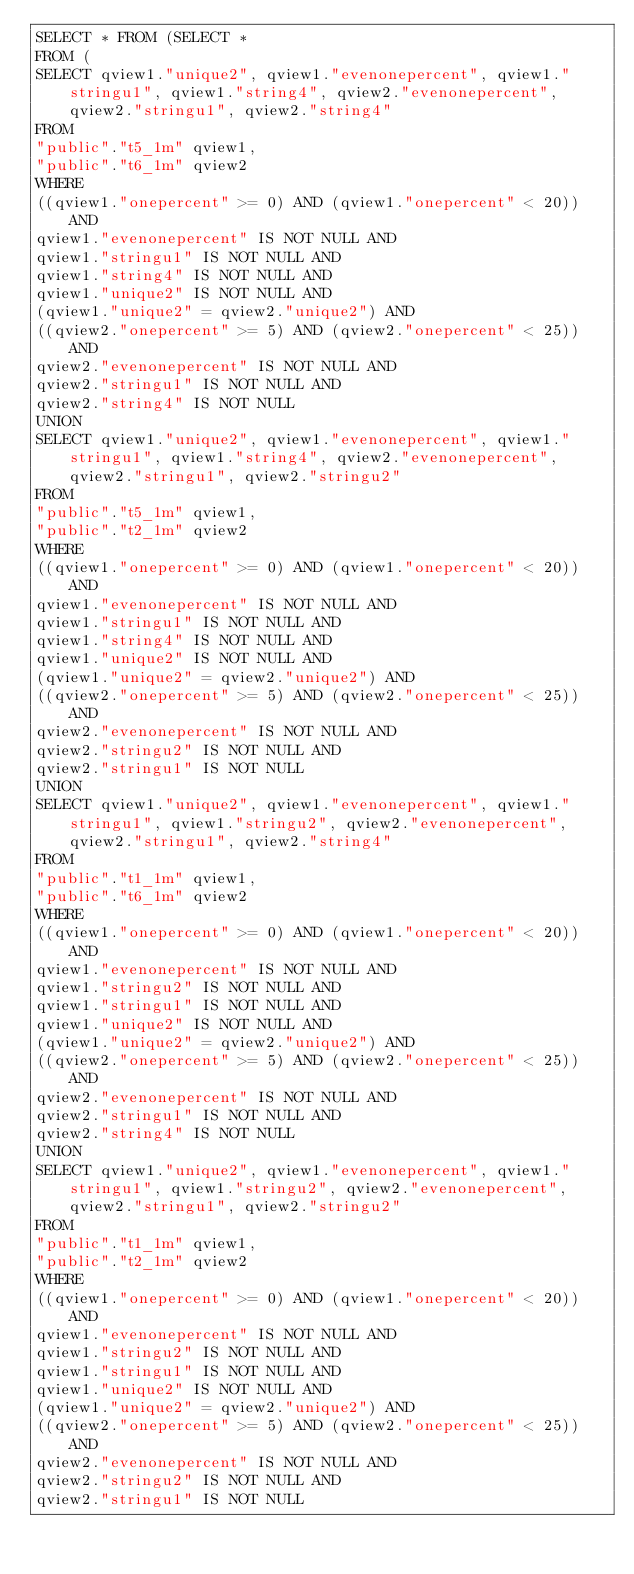Convert code to text. <code><loc_0><loc_0><loc_500><loc_500><_SQL_>SELECT * FROM (SELECT *
FROM (
SELECT qview1."unique2", qview1."evenonepercent", qview1."stringu1", qview1."string4", qview2."evenonepercent", qview2."stringu1", qview2."string4"
FROM
"public"."t5_1m" qview1,
"public"."t6_1m" qview2
WHERE
((qview1."onepercent" >= 0) AND (qview1."onepercent" < 20)) AND
qview1."evenonepercent" IS NOT NULL AND
qview1."stringu1" IS NOT NULL AND
qview1."string4" IS NOT NULL AND
qview1."unique2" IS NOT NULL AND
(qview1."unique2" = qview2."unique2") AND
((qview2."onepercent" >= 5) AND (qview2."onepercent" < 25)) AND
qview2."evenonepercent" IS NOT NULL AND
qview2."stringu1" IS NOT NULL AND
qview2."string4" IS NOT NULL
UNION
SELECT qview1."unique2", qview1."evenonepercent", qview1."stringu1", qview1."string4", qview2."evenonepercent", qview2."stringu1", qview2."stringu2"
FROM
"public"."t5_1m" qview1,
"public"."t2_1m" qview2
WHERE
((qview1."onepercent" >= 0) AND (qview1."onepercent" < 20)) AND
qview1."evenonepercent" IS NOT NULL AND
qview1."stringu1" IS NOT NULL AND
qview1."string4" IS NOT NULL AND
qview1."unique2" IS NOT NULL AND
(qview1."unique2" = qview2."unique2") AND
((qview2."onepercent" >= 5) AND (qview2."onepercent" < 25)) AND
qview2."evenonepercent" IS NOT NULL AND
qview2."stringu2" IS NOT NULL AND
qview2."stringu1" IS NOT NULL
UNION
SELECT qview1."unique2", qview1."evenonepercent", qview1."stringu1", qview1."stringu2", qview2."evenonepercent", qview2."stringu1", qview2."string4"
FROM
"public"."t1_1m" qview1,
"public"."t6_1m" qview2
WHERE
((qview1."onepercent" >= 0) AND (qview1."onepercent" < 20)) AND
qview1."evenonepercent" IS NOT NULL AND
qview1."stringu2" IS NOT NULL AND
qview1."stringu1" IS NOT NULL AND
qview1."unique2" IS NOT NULL AND
(qview1."unique2" = qview2."unique2") AND
((qview2."onepercent" >= 5) AND (qview2."onepercent" < 25)) AND
qview2."evenonepercent" IS NOT NULL AND
qview2."stringu1" IS NOT NULL AND
qview2."string4" IS NOT NULL
UNION
SELECT qview1."unique2", qview1."evenonepercent", qview1."stringu1", qview1."stringu2", qview2."evenonepercent", qview2."stringu1", qview2."stringu2"
FROM
"public"."t1_1m" qview1,
"public"."t2_1m" qview2
WHERE
((qview1."onepercent" >= 0) AND (qview1."onepercent" < 20)) AND
qview1."evenonepercent" IS NOT NULL AND
qview1."stringu2" IS NOT NULL AND
qview1."stringu1" IS NOT NULL AND
qview1."unique2" IS NOT NULL AND
(qview1."unique2" = qview2."unique2") AND
((qview2."onepercent" >= 5) AND (qview2."onepercent" < 25)) AND
qview2."evenonepercent" IS NOT NULL AND
qview2."stringu2" IS NOT NULL AND
qview2."stringu1" IS NOT NULL</code> 